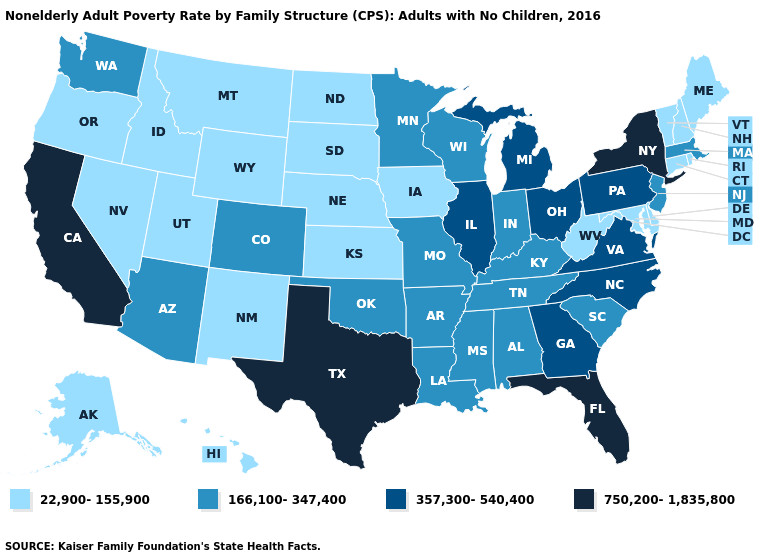Name the states that have a value in the range 750,200-1,835,800?
Concise answer only. California, Florida, New York, Texas. Which states have the lowest value in the South?
Short answer required. Delaware, Maryland, West Virginia. What is the value of Mississippi?
Short answer required. 166,100-347,400. Does Connecticut have the highest value in the USA?
Quick response, please. No. Among the states that border Minnesota , does Wisconsin have the highest value?
Write a very short answer. Yes. Name the states that have a value in the range 22,900-155,900?
Be succinct. Alaska, Connecticut, Delaware, Hawaii, Idaho, Iowa, Kansas, Maine, Maryland, Montana, Nebraska, Nevada, New Hampshire, New Mexico, North Dakota, Oregon, Rhode Island, South Dakota, Utah, Vermont, West Virginia, Wyoming. What is the lowest value in states that border Louisiana?
Write a very short answer. 166,100-347,400. Does Michigan have a lower value than Oklahoma?
Answer briefly. No. Among the states that border California , which have the lowest value?
Give a very brief answer. Nevada, Oregon. What is the value of Connecticut?
Be succinct. 22,900-155,900. Name the states that have a value in the range 166,100-347,400?
Give a very brief answer. Alabama, Arizona, Arkansas, Colorado, Indiana, Kentucky, Louisiana, Massachusetts, Minnesota, Mississippi, Missouri, New Jersey, Oklahoma, South Carolina, Tennessee, Washington, Wisconsin. Name the states that have a value in the range 357,300-540,400?
Keep it brief. Georgia, Illinois, Michigan, North Carolina, Ohio, Pennsylvania, Virginia. Name the states that have a value in the range 357,300-540,400?
Short answer required. Georgia, Illinois, Michigan, North Carolina, Ohio, Pennsylvania, Virginia. Name the states that have a value in the range 357,300-540,400?
Keep it brief. Georgia, Illinois, Michigan, North Carolina, Ohio, Pennsylvania, Virginia. What is the value of Rhode Island?
Be succinct. 22,900-155,900. 